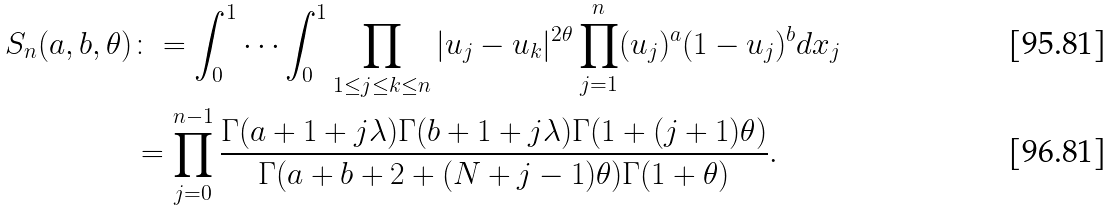<formula> <loc_0><loc_0><loc_500><loc_500>S _ { n } ( a , b , \theta ) & \colon = \int _ { 0 } ^ { 1 } \cdots \int _ { 0 } ^ { 1 } \prod _ { 1 \leq j \leq k \leq n } | u _ { j } - u _ { k } | ^ { 2 \theta } \prod _ { j = 1 } ^ { n } ( u _ { j } ) ^ { a } ( 1 - u _ { j } ) ^ { b } d x _ { j } \\ & = \prod _ { j = 0 } ^ { n - 1 } \frac { \Gamma ( a + 1 + j \lambda ) \Gamma ( b + 1 + j \lambda ) \Gamma ( 1 + ( j + 1 ) \theta ) } { \Gamma ( a + b + 2 + ( N + j - 1 ) \theta ) \Gamma ( 1 + \theta ) } .</formula> 